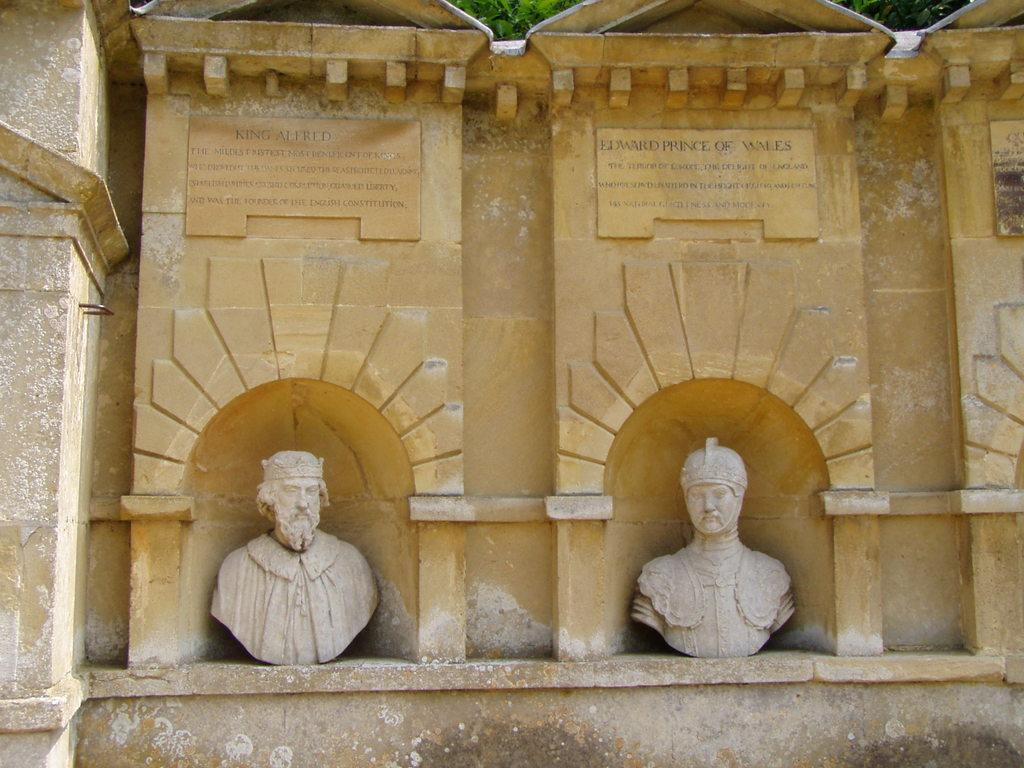What can be seen in the image? There are statues in the image. What is visible in the background of the image? There is a wall in the background of the image. Are there any police officers or boats involved in an attack in the image? No, there are no police officers, boats, or any indication of an attack in the image. The image only features statues and a wall in the background. 